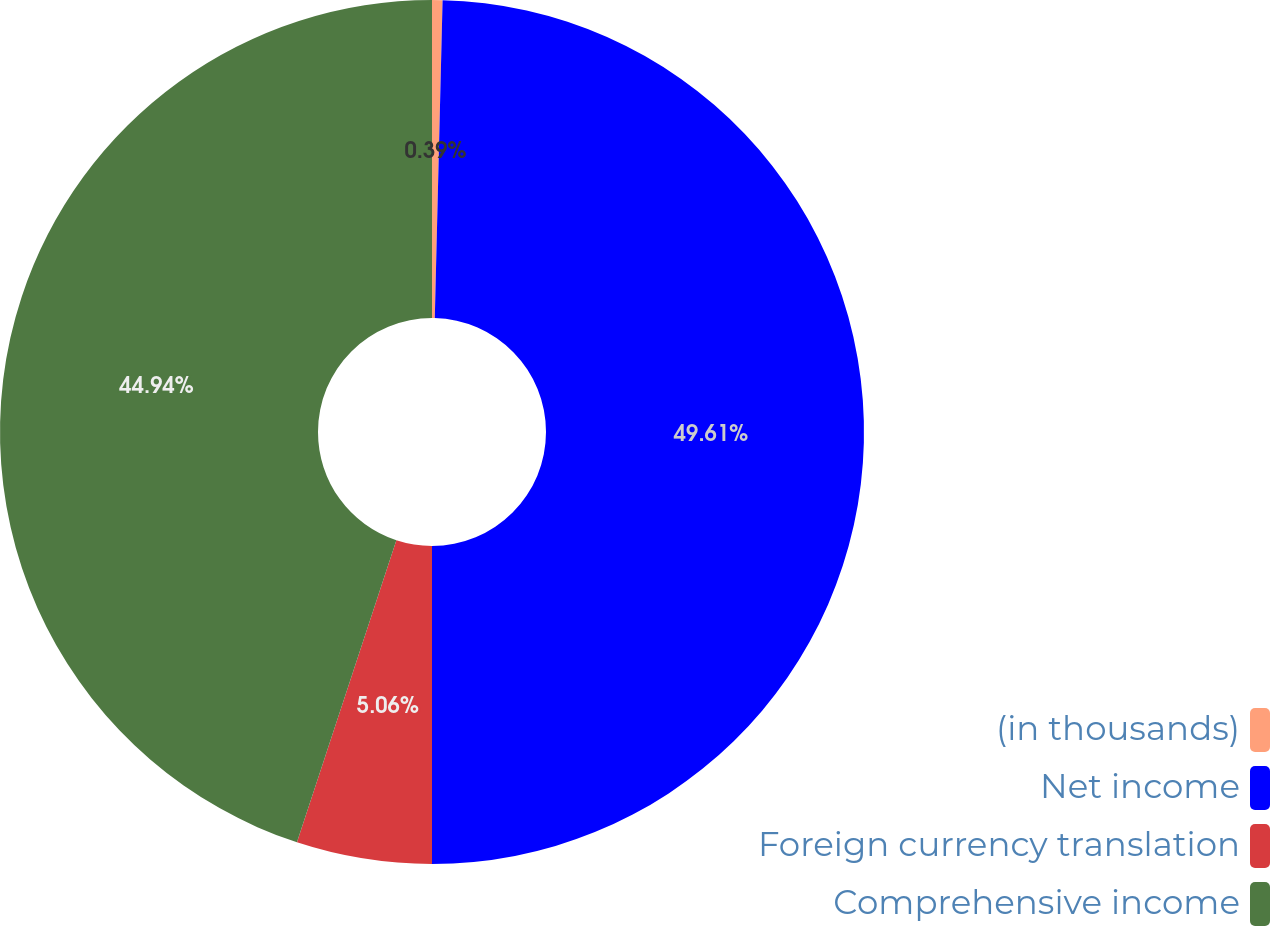<chart> <loc_0><loc_0><loc_500><loc_500><pie_chart><fcel>(in thousands)<fcel>Net income<fcel>Foreign currency translation<fcel>Comprehensive income<nl><fcel>0.39%<fcel>49.61%<fcel>5.06%<fcel>44.94%<nl></chart> 